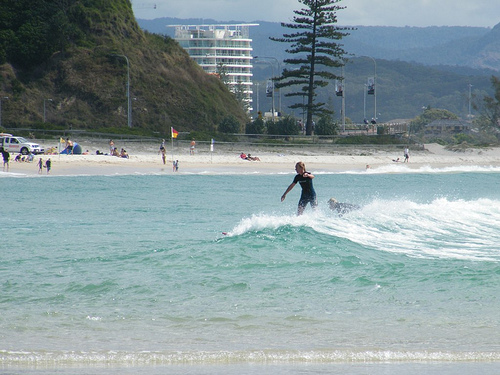Please provide the bounding box coordinate of the region this sentence describes: the man laying in the water. The bounding box coordinates for the man laying in the water are [0.65, 0.51, 0.75, 0.57]. These coordinates highlight the region where a man is relaxing in the water near the shore. 